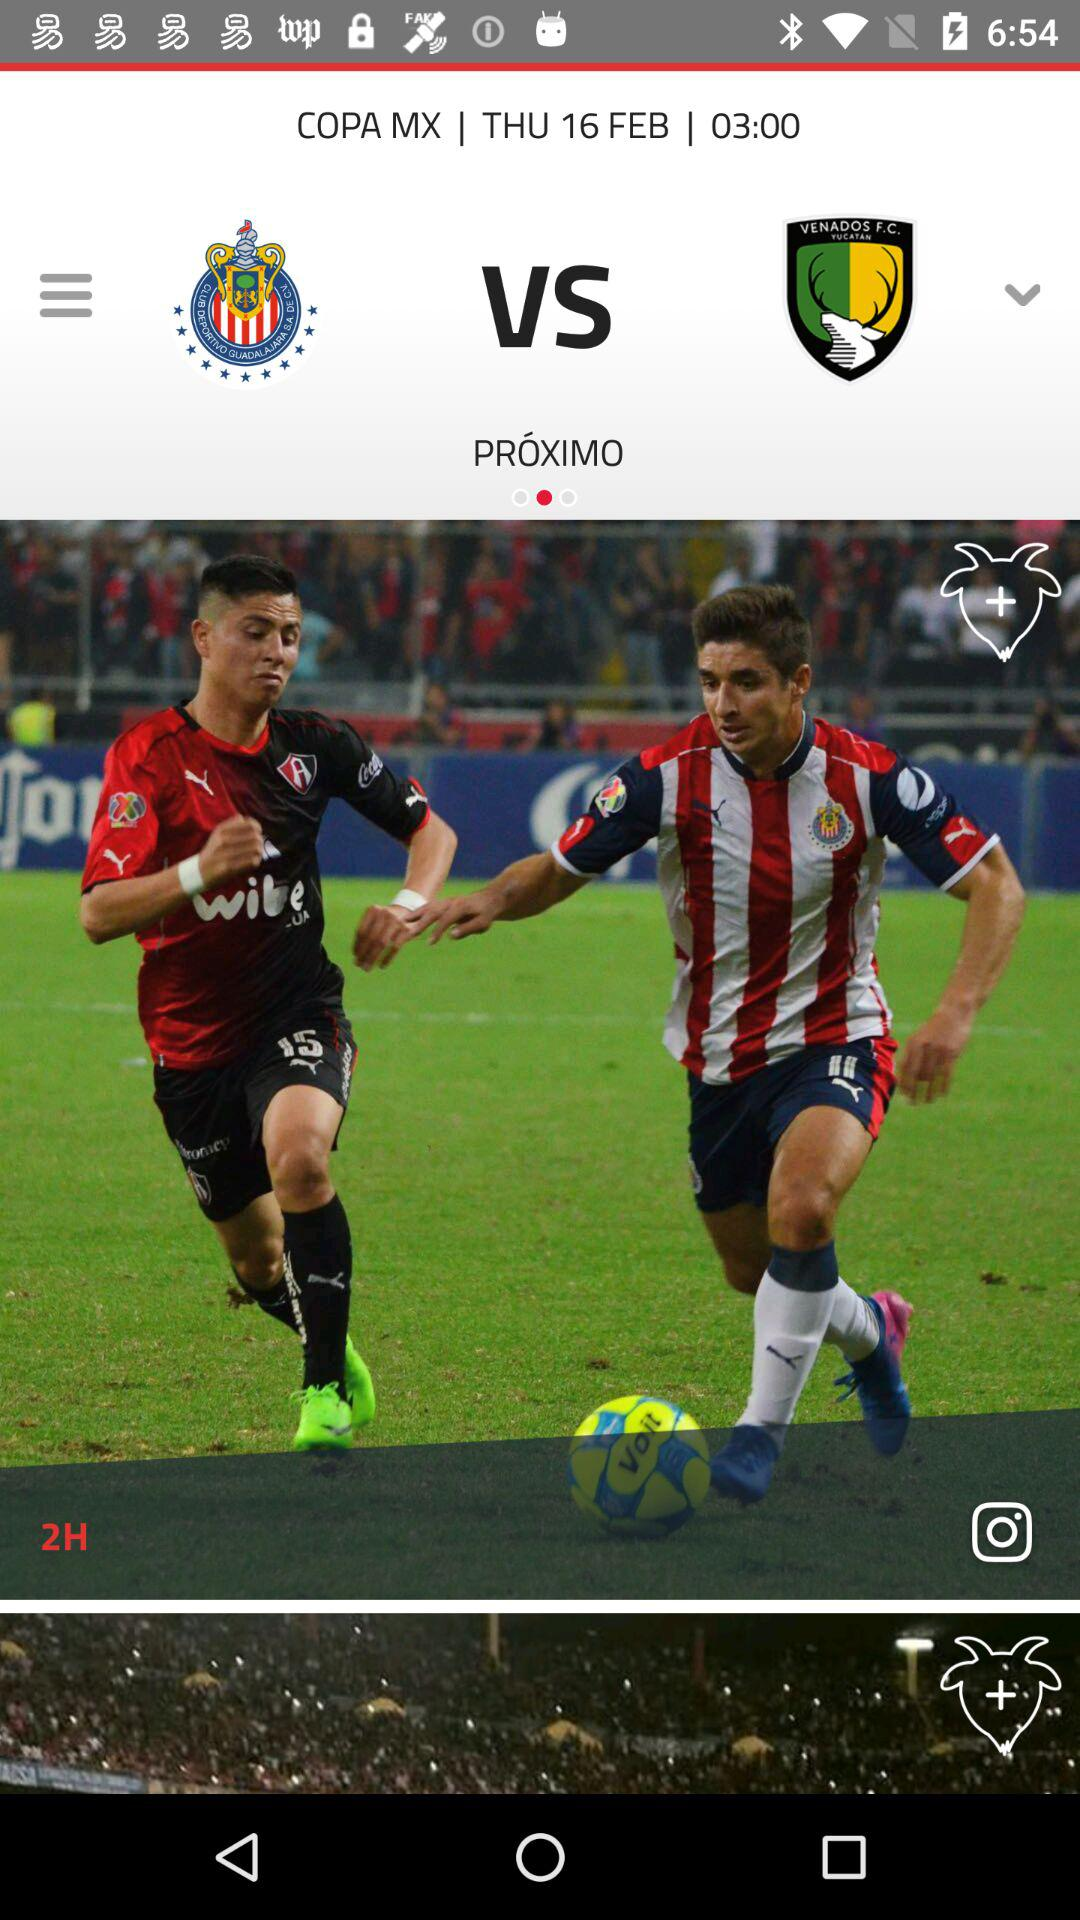How many teams are playing in the game? There are two teams playing in the game, as indicated by the image displaying two distinct team emblems with a 'VS' symbol between them, signifying a match-up. 